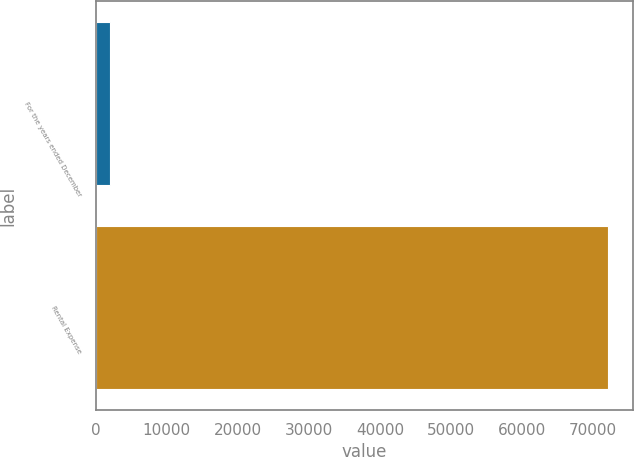Convert chart. <chart><loc_0><loc_0><loc_500><loc_500><bar_chart><fcel>For the years ended December<fcel>Rental Expense<nl><fcel>2017<fcel>72030<nl></chart> 